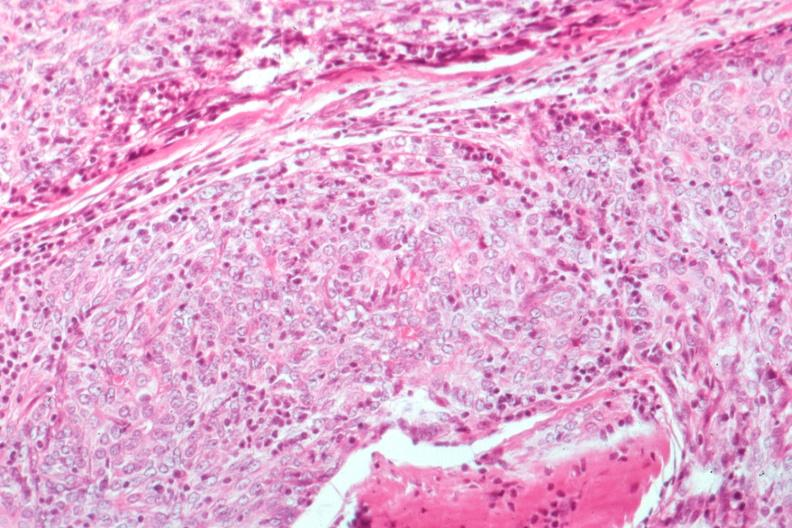what is present?
Answer the question using a single word or phrase. Thymus 